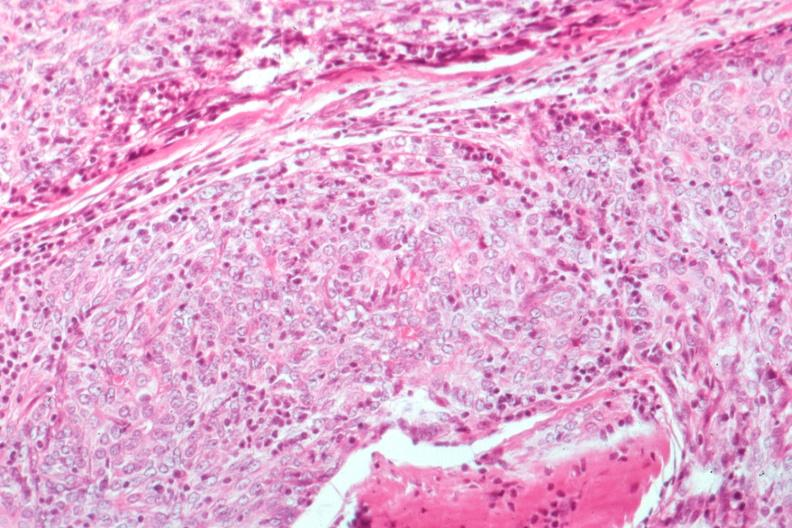what is present?
Answer the question using a single word or phrase. Thymus 